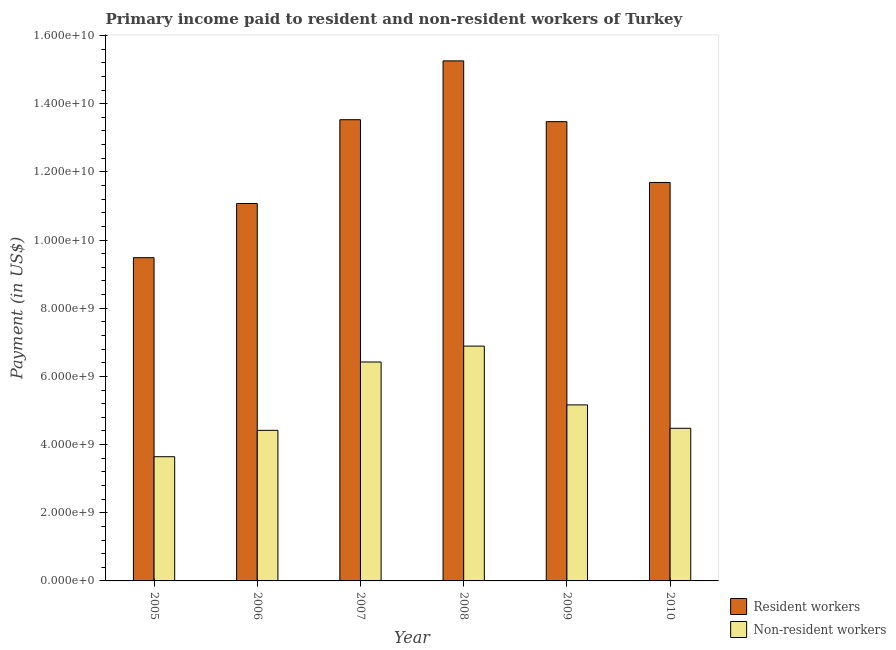How many groups of bars are there?
Provide a short and direct response. 6. Are the number of bars on each tick of the X-axis equal?
Provide a short and direct response. Yes. What is the label of the 5th group of bars from the left?
Give a very brief answer. 2009. In how many cases, is the number of bars for a given year not equal to the number of legend labels?
Provide a short and direct response. 0. What is the payment made to resident workers in 2010?
Your answer should be compact. 1.17e+1. Across all years, what is the maximum payment made to resident workers?
Provide a succinct answer. 1.53e+1. Across all years, what is the minimum payment made to non-resident workers?
Give a very brief answer. 3.64e+09. In which year was the payment made to resident workers maximum?
Keep it short and to the point. 2008. What is the total payment made to resident workers in the graph?
Provide a short and direct response. 7.45e+1. What is the difference between the payment made to non-resident workers in 2006 and that in 2008?
Ensure brevity in your answer.  -2.47e+09. What is the difference between the payment made to non-resident workers in 2005 and the payment made to resident workers in 2006?
Keep it short and to the point. -7.74e+08. What is the average payment made to non-resident workers per year?
Make the answer very short. 5.17e+09. What is the ratio of the payment made to resident workers in 2005 to that in 2009?
Offer a very short reply. 0.7. What is the difference between the highest and the second highest payment made to non-resident workers?
Offer a very short reply. 4.66e+08. What is the difference between the highest and the lowest payment made to resident workers?
Your answer should be compact. 5.77e+09. Is the sum of the payment made to non-resident workers in 2005 and 2007 greater than the maximum payment made to resident workers across all years?
Offer a terse response. Yes. What does the 1st bar from the left in 2005 represents?
Your answer should be compact. Resident workers. What does the 1st bar from the right in 2007 represents?
Your answer should be very brief. Non-resident workers. How many bars are there?
Offer a very short reply. 12. Are all the bars in the graph horizontal?
Your response must be concise. No. How many years are there in the graph?
Give a very brief answer. 6. Does the graph contain any zero values?
Keep it short and to the point. No. Does the graph contain grids?
Provide a succinct answer. No. Where does the legend appear in the graph?
Offer a terse response. Bottom right. How many legend labels are there?
Your response must be concise. 2. How are the legend labels stacked?
Your answer should be very brief. Vertical. What is the title of the graph?
Offer a terse response. Primary income paid to resident and non-resident workers of Turkey. Does "External balance on goods" appear as one of the legend labels in the graph?
Your answer should be very brief. No. What is the label or title of the X-axis?
Your response must be concise. Year. What is the label or title of the Y-axis?
Give a very brief answer. Payment (in US$). What is the Payment (in US$) of Resident workers in 2005?
Keep it short and to the point. 9.48e+09. What is the Payment (in US$) of Non-resident workers in 2005?
Your answer should be very brief. 3.64e+09. What is the Payment (in US$) of Resident workers in 2006?
Give a very brief answer. 1.11e+1. What is the Payment (in US$) in Non-resident workers in 2006?
Provide a short and direct response. 4.42e+09. What is the Payment (in US$) in Resident workers in 2007?
Give a very brief answer. 1.35e+1. What is the Payment (in US$) in Non-resident workers in 2007?
Give a very brief answer. 6.42e+09. What is the Payment (in US$) of Resident workers in 2008?
Ensure brevity in your answer.  1.53e+1. What is the Payment (in US$) in Non-resident workers in 2008?
Your answer should be very brief. 6.89e+09. What is the Payment (in US$) of Resident workers in 2009?
Your response must be concise. 1.35e+1. What is the Payment (in US$) of Non-resident workers in 2009?
Ensure brevity in your answer.  5.16e+09. What is the Payment (in US$) of Resident workers in 2010?
Your answer should be compact. 1.17e+1. What is the Payment (in US$) of Non-resident workers in 2010?
Your answer should be compact. 4.48e+09. Across all years, what is the maximum Payment (in US$) of Resident workers?
Provide a succinct answer. 1.53e+1. Across all years, what is the maximum Payment (in US$) in Non-resident workers?
Keep it short and to the point. 6.89e+09. Across all years, what is the minimum Payment (in US$) of Resident workers?
Provide a short and direct response. 9.48e+09. Across all years, what is the minimum Payment (in US$) in Non-resident workers?
Keep it short and to the point. 3.64e+09. What is the total Payment (in US$) of Resident workers in the graph?
Offer a very short reply. 7.45e+1. What is the total Payment (in US$) of Non-resident workers in the graph?
Provide a short and direct response. 3.10e+1. What is the difference between the Payment (in US$) of Resident workers in 2005 and that in 2006?
Make the answer very short. -1.59e+09. What is the difference between the Payment (in US$) in Non-resident workers in 2005 and that in 2006?
Provide a succinct answer. -7.74e+08. What is the difference between the Payment (in US$) in Resident workers in 2005 and that in 2007?
Your answer should be very brief. -4.05e+09. What is the difference between the Payment (in US$) in Non-resident workers in 2005 and that in 2007?
Your answer should be compact. -2.78e+09. What is the difference between the Payment (in US$) of Resident workers in 2005 and that in 2008?
Your answer should be compact. -5.77e+09. What is the difference between the Payment (in US$) in Non-resident workers in 2005 and that in 2008?
Keep it short and to the point. -3.24e+09. What is the difference between the Payment (in US$) in Resident workers in 2005 and that in 2009?
Keep it short and to the point. -3.99e+09. What is the difference between the Payment (in US$) of Non-resident workers in 2005 and that in 2009?
Your answer should be very brief. -1.52e+09. What is the difference between the Payment (in US$) in Resident workers in 2005 and that in 2010?
Offer a very short reply. -2.21e+09. What is the difference between the Payment (in US$) of Non-resident workers in 2005 and that in 2010?
Your response must be concise. -8.34e+08. What is the difference between the Payment (in US$) in Resident workers in 2006 and that in 2007?
Make the answer very short. -2.46e+09. What is the difference between the Payment (in US$) of Non-resident workers in 2006 and that in 2007?
Offer a very short reply. -2.00e+09. What is the difference between the Payment (in US$) in Resident workers in 2006 and that in 2008?
Provide a succinct answer. -4.18e+09. What is the difference between the Payment (in US$) of Non-resident workers in 2006 and that in 2008?
Your answer should be compact. -2.47e+09. What is the difference between the Payment (in US$) in Resident workers in 2006 and that in 2009?
Your answer should be very brief. -2.40e+09. What is the difference between the Payment (in US$) of Non-resident workers in 2006 and that in 2009?
Your answer should be compact. -7.46e+08. What is the difference between the Payment (in US$) in Resident workers in 2006 and that in 2010?
Make the answer very short. -6.17e+08. What is the difference between the Payment (in US$) of Non-resident workers in 2006 and that in 2010?
Provide a succinct answer. -6.00e+07. What is the difference between the Payment (in US$) in Resident workers in 2007 and that in 2008?
Provide a short and direct response. -1.73e+09. What is the difference between the Payment (in US$) of Non-resident workers in 2007 and that in 2008?
Keep it short and to the point. -4.66e+08. What is the difference between the Payment (in US$) of Resident workers in 2007 and that in 2009?
Ensure brevity in your answer.  5.70e+07. What is the difference between the Payment (in US$) of Non-resident workers in 2007 and that in 2009?
Offer a terse response. 1.26e+09. What is the difference between the Payment (in US$) of Resident workers in 2007 and that in 2010?
Your answer should be compact. 1.84e+09. What is the difference between the Payment (in US$) of Non-resident workers in 2007 and that in 2010?
Ensure brevity in your answer.  1.94e+09. What is the difference between the Payment (in US$) of Resident workers in 2008 and that in 2009?
Provide a succinct answer. 1.78e+09. What is the difference between the Payment (in US$) of Non-resident workers in 2008 and that in 2009?
Keep it short and to the point. 1.72e+09. What is the difference between the Payment (in US$) in Resident workers in 2008 and that in 2010?
Keep it short and to the point. 3.57e+09. What is the difference between the Payment (in US$) of Non-resident workers in 2008 and that in 2010?
Provide a succinct answer. 2.41e+09. What is the difference between the Payment (in US$) of Resident workers in 2009 and that in 2010?
Provide a succinct answer. 1.78e+09. What is the difference between the Payment (in US$) of Non-resident workers in 2009 and that in 2010?
Keep it short and to the point. 6.86e+08. What is the difference between the Payment (in US$) in Resident workers in 2005 and the Payment (in US$) in Non-resident workers in 2006?
Offer a very short reply. 5.06e+09. What is the difference between the Payment (in US$) in Resident workers in 2005 and the Payment (in US$) in Non-resident workers in 2007?
Offer a terse response. 3.06e+09. What is the difference between the Payment (in US$) of Resident workers in 2005 and the Payment (in US$) of Non-resident workers in 2008?
Ensure brevity in your answer.  2.59e+09. What is the difference between the Payment (in US$) in Resident workers in 2005 and the Payment (in US$) in Non-resident workers in 2009?
Give a very brief answer. 4.32e+09. What is the difference between the Payment (in US$) of Resident workers in 2005 and the Payment (in US$) of Non-resident workers in 2010?
Keep it short and to the point. 5.00e+09. What is the difference between the Payment (in US$) of Resident workers in 2006 and the Payment (in US$) of Non-resident workers in 2007?
Provide a succinct answer. 4.65e+09. What is the difference between the Payment (in US$) in Resident workers in 2006 and the Payment (in US$) in Non-resident workers in 2008?
Your response must be concise. 4.18e+09. What is the difference between the Payment (in US$) of Resident workers in 2006 and the Payment (in US$) of Non-resident workers in 2009?
Offer a very short reply. 5.91e+09. What is the difference between the Payment (in US$) in Resident workers in 2006 and the Payment (in US$) in Non-resident workers in 2010?
Offer a terse response. 6.60e+09. What is the difference between the Payment (in US$) in Resident workers in 2007 and the Payment (in US$) in Non-resident workers in 2008?
Your response must be concise. 6.64e+09. What is the difference between the Payment (in US$) of Resident workers in 2007 and the Payment (in US$) of Non-resident workers in 2009?
Provide a succinct answer. 8.37e+09. What is the difference between the Payment (in US$) of Resident workers in 2007 and the Payment (in US$) of Non-resident workers in 2010?
Provide a short and direct response. 9.05e+09. What is the difference between the Payment (in US$) of Resident workers in 2008 and the Payment (in US$) of Non-resident workers in 2009?
Offer a very short reply. 1.01e+1. What is the difference between the Payment (in US$) of Resident workers in 2008 and the Payment (in US$) of Non-resident workers in 2010?
Your answer should be compact. 1.08e+1. What is the difference between the Payment (in US$) of Resident workers in 2009 and the Payment (in US$) of Non-resident workers in 2010?
Offer a very short reply. 9.00e+09. What is the average Payment (in US$) of Resident workers per year?
Keep it short and to the point. 1.24e+1. What is the average Payment (in US$) of Non-resident workers per year?
Make the answer very short. 5.17e+09. In the year 2005, what is the difference between the Payment (in US$) of Resident workers and Payment (in US$) of Non-resident workers?
Offer a very short reply. 5.84e+09. In the year 2006, what is the difference between the Payment (in US$) in Resident workers and Payment (in US$) in Non-resident workers?
Your answer should be compact. 6.66e+09. In the year 2007, what is the difference between the Payment (in US$) of Resident workers and Payment (in US$) of Non-resident workers?
Provide a short and direct response. 7.11e+09. In the year 2008, what is the difference between the Payment (in US$) in Resident workers and Payment (in US$) in Non-resident workers?
Your answer should be very brief. 8.37e+09. In the year 2009, what is the difference between the Payment (in US$) in Resident workers and Payment (in US$) in Non-resident workers?
Your answer should be very brief. 8.31e+09. In the year 2010, what is the difference between the Payment (in US$) of Resident workers and Payment (in US$) of Non-resident workers?
Make the answer very short. 7.21e+09. What is the ratio of the Payment (in US$) of Resident workers in 2005 to that in 2006?
Your response must be concise. 0.86. What is the ratio of the Payment (in US$) in Non-resident workers in 2005 to that in 2006?
Ensure brevity in your answer.  0.82. What is the ratio of the Payment (in US$) of Resident workers in 2005 to that in 2007?
Give a very brief answer. 0.7. What is the ratio of the Payment (in US$) of Non-resident workers in 2005 to that in 2007?
Offer a terse response. 0.57. What is the ratio of the Payment (in US$) of Resident workers in 2005 to that in 2008?
Your answer should be compact. 0.62. What is the ratio of the Payment (in US$) of Non-resident workers in 2005 to that in 2008?
Give a very brief answer. 0.53. What is the ratio of the Payment (in US$) of Resident workers in 2005 to that in 2009?
Offer a terse response. 0.7. What is the ratio of the Payment (in US$) in Non-resident workers in 2005 to that in 2009?
Make the answer very short. 0.71. What is the ratio of the Payment (in US$) of Resident workers in 2005 to that in 2010?
Your answer should be very brief. 0.81. What is the ratio of the Payment (in US$) of Non-resident workers in 2005 to that in 2010?
Your answer should be compact. 0.81. What is the ratio of the Payment (in US$) in Resident workers in 2006 to that in 2007?
Your answer should be very brief. 0.82. What is the ratio of the Payment (in US$) in Non-resident workers in 2006 to that in 2007?
Provide a short and direct response. 0.69. What is the ratio of the Payment (in US$) in Resident workers in 2006 to that in 2008?
Make the answer very short. 0.73. What is the ratio of the Payment (in US$) of Non-resident workers in 2006 to that in 2008?
Keep it short and to the point. 0.64. What is the ratio of the Payment (in US$) in Resident workers in 2006 to that in 2009?
Offer a terse response. 0.82. What is the ratio of the Payment (in US$) of Non-resident workers in 2006 to that in 2009?
Provide a succinct answer. 0.86. What is the ratio of the Payment (in US$) in Resident workers in 2006 to that in 2010?
Ensure brevity in your answer.  0.95. What is the ratio of the Payment (in US$) of Non-resident workers in 2006 to that in 2010?
Your answer should be compact. 0.99. What is the ratio of the Payment (in US$) of Resident workers in 2007 to that in 2008?
Keep it short and to the point. 0.89. What is the ratio of the Payment (in US$) of Non-resident workers in 2007 to that in 2008?
Give a very brief answer. 0.93. What is the ratio of the Payment (in US$) in Resident workers in 2007 to that in 2009?
Offer a terse response. 1. What is the ratio of the Payment (in US$) in Non-resident workers in 2007 to that in 2009?
Give a very brief answer. 1.24. What is the ratio of the Payment (in US$) in Resident workers in 2007 to that in 2010?
Offer a terse response. 1.16. What is the ratio of the Payment (in US$) of Non-resident workers in 2007 to that in 2010?
Ensure brevity in your answer.  1.43. What is the ratio of the Payment (in US$) in Resident workers in 2008 to that in 2009?
Your response must be concise. 1.13. What is the ratio of the Payment (in US$) in Non-resident workers in 2008 to that in 2009?
Your answer should be compact. 1.33. What is the ratio of the Payment (in US$) in Resident workers in 2008 to that in 2010?
Your answer should be very brief. 1.31. What is the ratio of the Payment (in US$) of Non-resident workers in 2008 to that in 2010?
Your answer should be compact. 1.54. What is the ratio of the Payment (in US$) of Resident workers in 2009 to that in 2010?
Your response must be concise. 1.15. What is the ratio of the Payment (in US$) of Non-resident workers in 2009 to that in 2010?
Give a very brief answer. 1.15. What is the difference between the highest and the second highest Payment (in US$) in Resident workers?
Offer a very short reply. 1.73e+09. What is the difference between the highest and the second highest Payment (in US$) in Non-resident workers?
Offer a terse response. 4.66e+08. What is the difference between the highest and the lowest Payment (in US$) of Resident workers?
Give a very brief answer. 5.77e+09. What is the difference between the highest and the lowest Payment (in US$) in Non-resident workers?
Offer a very short reply. 3.24e+09. 